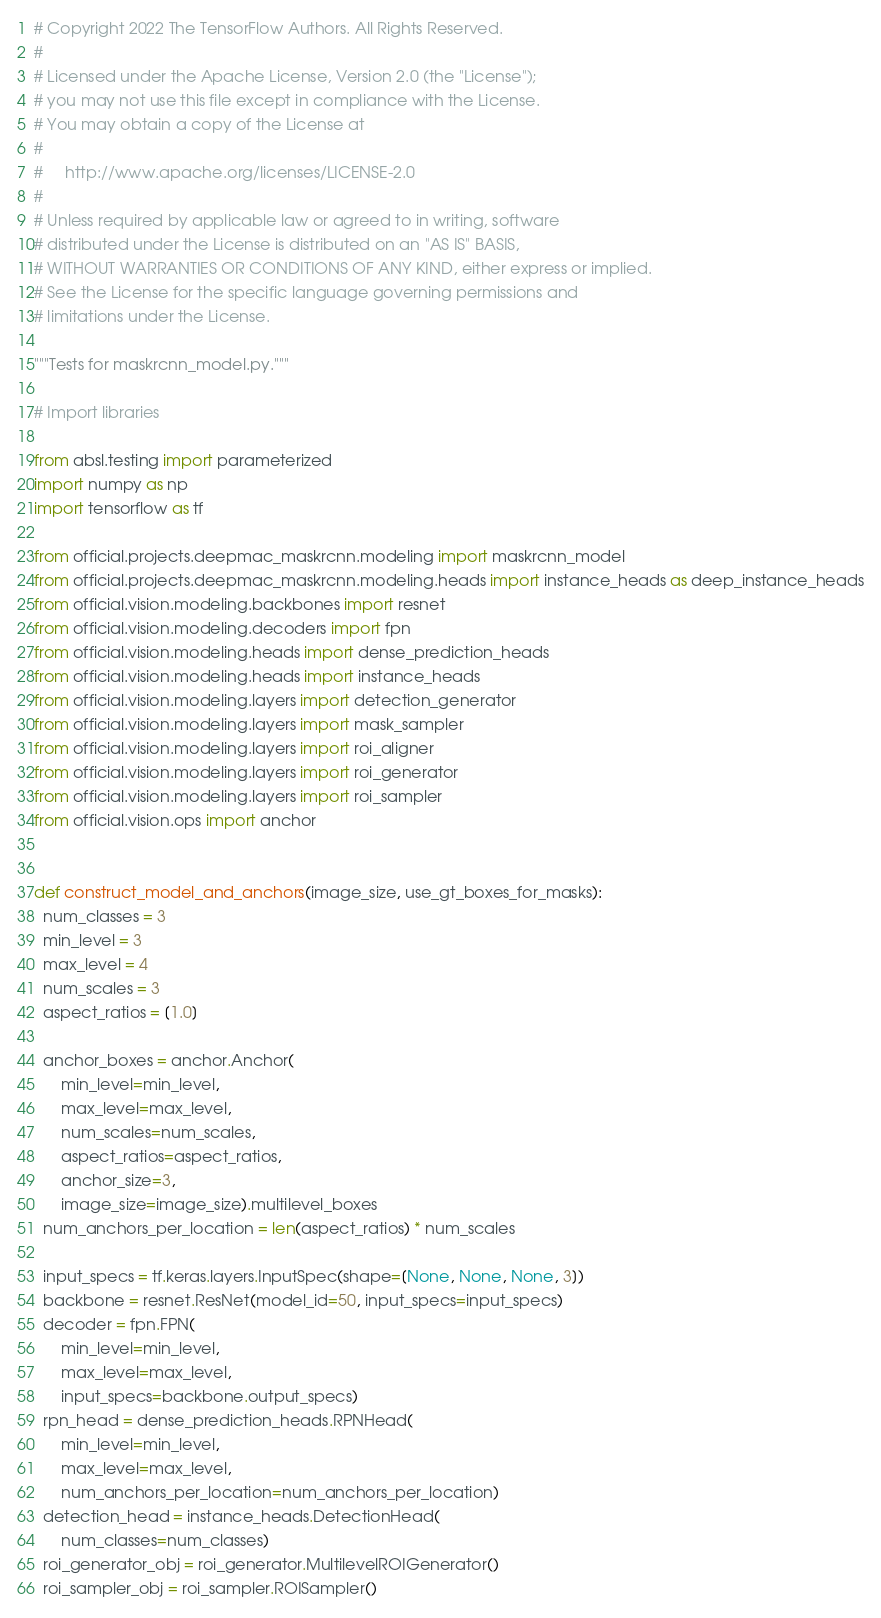<code> <loc_0><loc_0><loc_500><loc_500><_Python_># Copyright 2022 The TensorFlow Authors. All Rights Reserved.
#
# Licensed under the Apache License, Version 2.0 (the "License");
# you may not use this file except in compliance with the License.
# You may obtain a copy of the License at
#
#     http://www.apache.org/licenses/LICENSE-2.0
#
# Unless required by applicable law or agreed to in writing, software
# distributed under the License is distributed on an "AS IS" BASIS,
# WITHOUT WARRANTIES OR CONDITIONS OF ANY KIND, either express or implied.
# See the License for the specific language governing permissions and
# limitations under the License.

"""Tests for maskrcnn_model.py."""

# Import libraries

from absl.testing import parameterized
import numpy as np
import tensorflow as tf

from official.projects.deepmac_maskrcnn.modeling import maskrcnn_model
from official.projects.deepmac_maskrcnn.modeling.heads import instance_heads as deep_instance_heads
from official.vision.modeling.backbones import resnet
from official.vision.modeling.decoders import fpn
from official.vision.modeling.heads import dense_prediction_heads
from official.vision.modeling.heads import instance_heads
from official.vision.modeling.layers import detection_generator
from official.vision.modeling.layers import mask_sampler
from official.vision.modeling.layers import roi_aligner
from official.vision.modeling.layers import roi_generator
from official.vision.modeling.layers import roi_sampler
from official.vision.ops import anchor


def construct_model_and_anchors(image_size, use_gt_boxes_for_masks):
  num_classes = 3
  min_level = 3
  max_level = 4
  num_scales = 3
  aspect_ratios = [1.0]

  anchor_boxes = anchor.Anchor(
      min_level=min_level,
      max_level=max_level,
      num_scales=num_scales,
      aspect_ratios=aspect_ratios,
      anchor_size=3,
      image_size=image_size).multilevel_boxes
  num_anchors_per_location = len(aspect_ratios) * num_scales

  input_specs = tf.keras.layers.InputSpec(shape=[None, None, None, 3])
  backbone = resnet.ResNet(model_id=50, input_specs=input_specs)
  decoder = fpn.FPN(
      min_level=min_level,
      max_level=max_level,
      input_specs=backbone.output_specs)
  rpn_head = dense_prediction_heads.RPNHead(
      min_level=min_level,
      max_level=max_level,
      num_anchors_per_location=num_anchors_per_location)
  detection_head = instance_heads.DetectionHead(
      num_classes=num_classes)
  roi_generator_obj = roi_generator.MultilevelROIGenerator()
  roi_sampler_obj = roi_sampler.ROISampler()</code> 